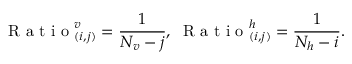<formula> <loc_0><loc_0><loc_500><loc_500>R a t i o _ { ( i , j ) } ^ { v } = \frac { 1 } { N _ { v } - j } , \, R a t i o _ { ( i , j ) } ^ { h } = \frac { 1 } { N _ { h } - i } .</formula> 